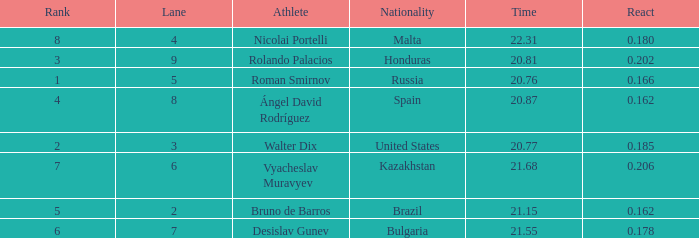Would you mind parsing the complete table? {'header': ['Rank', 'Lane', 'Athlete', 'Nationality', 'Time', 'React'], 'rows': [['8', '4', 'Nicolai Portelli', 'Malta', '22.31', '0.180'], ['3', '9', 'Rolando Palacios', 'Honduras', '20.81', '0.202'], ['1', '5', 'Roman Smirnov', 'Russia', '20.76', '0.166'], ['4', '8', 'Ángel David Rodríguez', 'Spain', '20.87', '0.162'], ['2', '3', 'Walter Dix', 'United States', '20.77', '0.185'], ['7', '6', 'Vyacheslav Muravyev', 'Kazakhstan', '21.68', '0.206'], ['5', '2', 'Bruno de Barros', 'Brazil', '21.15', '0.162'], ['6', '7', 'Desislav Gunev', 'Bulgaria', '21.55', '0.178']]} What's Bulgaria's lane with a time more than 21.55? None. 